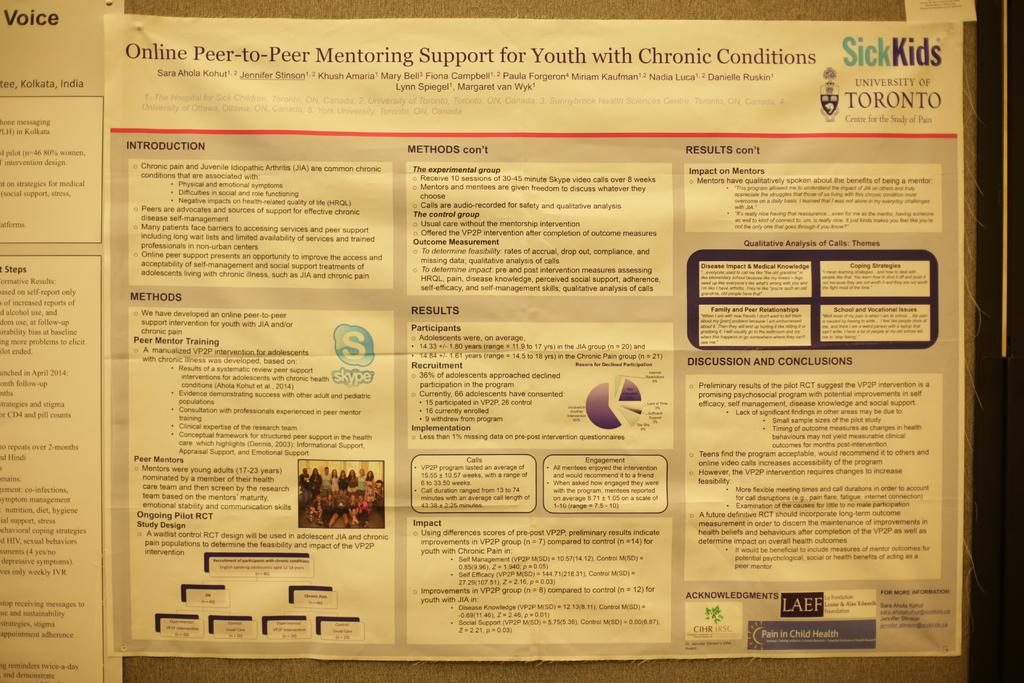<image>
Create a compact narrative representing the image presented. An informational page for children with chronic conditions by Sick Kids. 